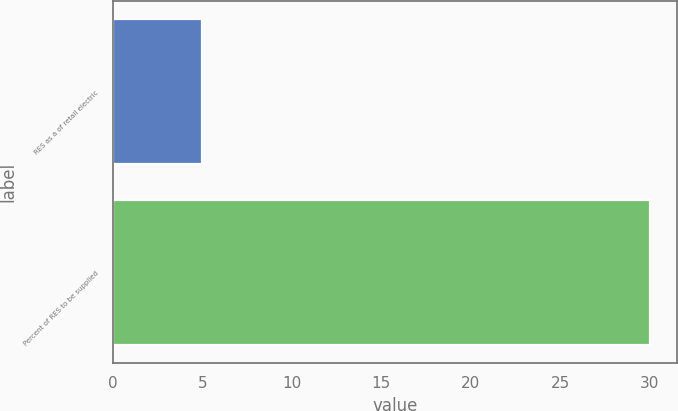Convert chart to OTSL. <chart><loc_0><loc_0><loc_500><loc_500><bar_chart><fcel>RES as a of retail electric<fcel>Percent of RES to be supplied<nl><fcel>5<fcel>30<nl></chart> 